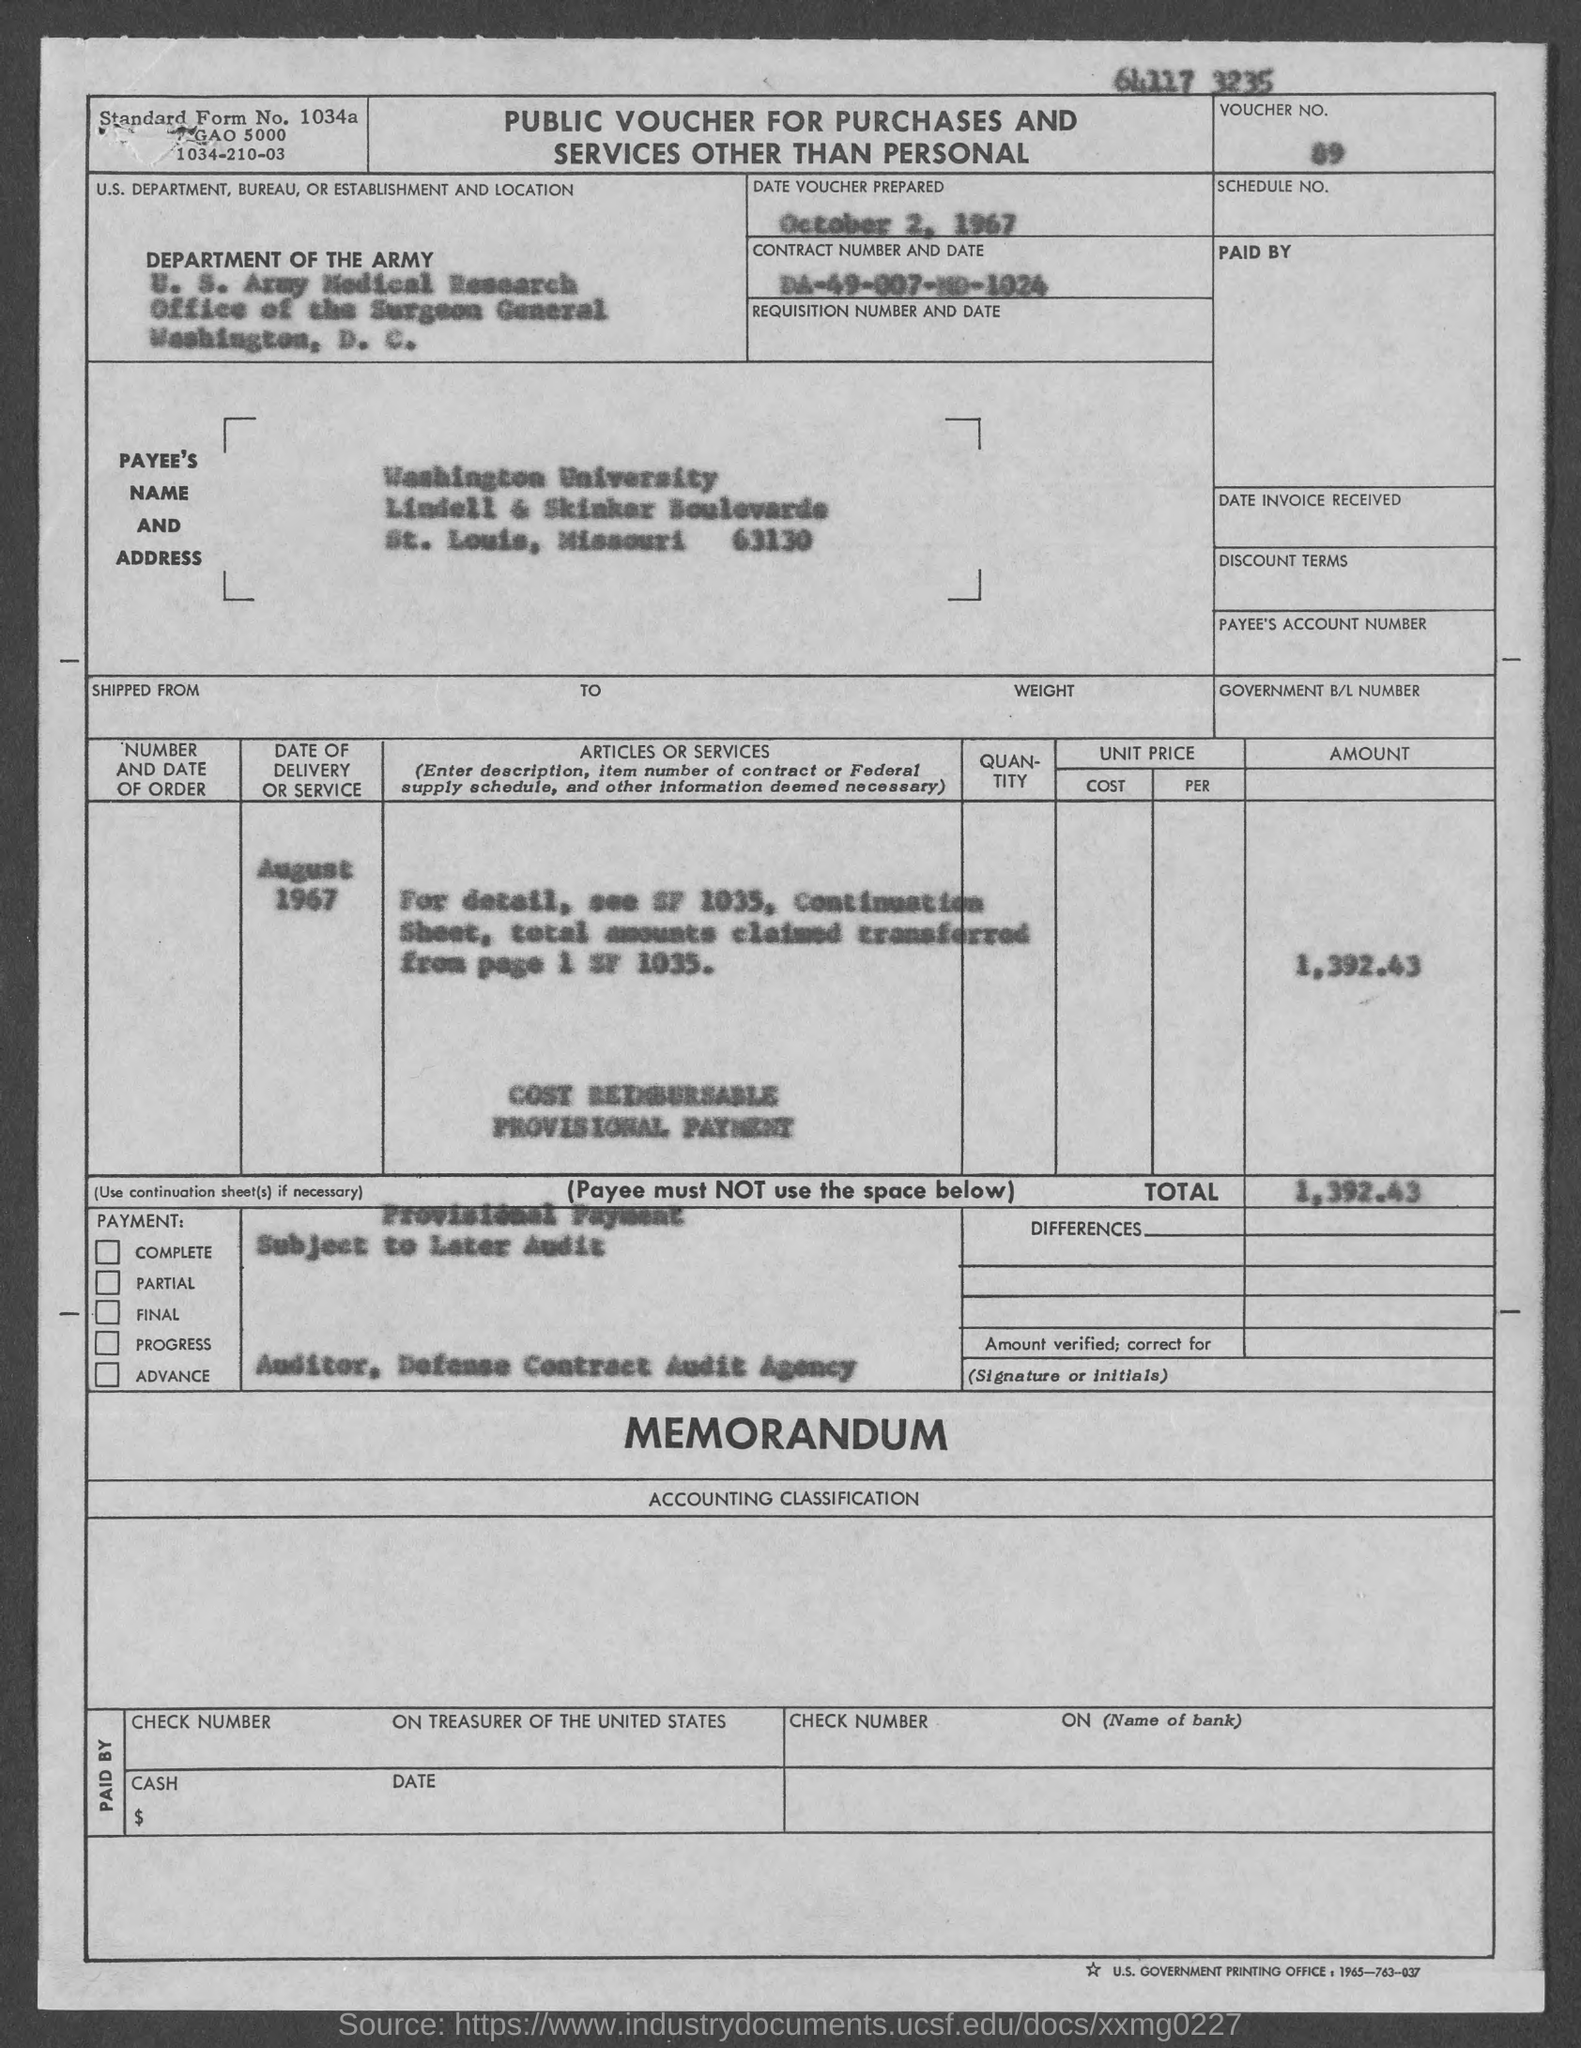Indicate a few pertinent items in this graphic. The standard form number listed in the voucher is 1034a... The voucher number mentioned in the document is 89... The payee's name listed in the voucher is "Washington University. The date of delivery of the service, as mentioned in the voucher, is August 1967. The voucher was prepared on October 2, 1967. 